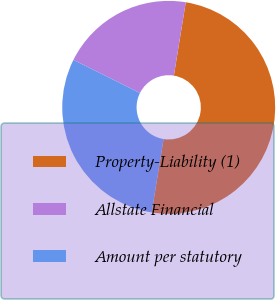Convert chart. <chart><loc_0><loc_0><loc_500><loc_500><pie_chart><fcel>Property-Liability (1)<fcel>Allstate Financial<fcel>Amount per statutory<nl><fcel>50.0%<fcel>20.21%<fcel>29.79%<nl></chart> 